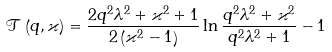Convert formula to latex. <formula><loc_0><loc_0><loc_500><loc_500>\mathcal { T } \left ( q , \varkappa \right ) = \frac { 2 q ^ { 2 } \lambda ^ { 2 } + \varkappa ^ { 2 } + 1 } { 2 \left ( \varkappa ^ { 2 } - 1 \right ) } \ln \frac { q ^ { 2 } \lambda ^ { 2 } + \varkappa ^ { 2 } } { q ^ { 2 } \lambda ^ { 2 } + 1 } - 1</formula> 